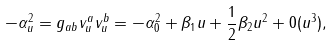Convert formula to latex. <formula><loc_0><loc_0><loc_500><loc_500>- \alpha _ { u } ^ { 2 } = g _ { a b } v _ { u } ^ { a } v _ { u } ^ { b } = - \alpha _ { 0 } ^ { 2 } + \beta _ { 1 } u + \frac { 1 } { 2 } \beta _ { 2 } u ^ { 2 } + 0 ( u ^ { 3 } ) ,</formula> 